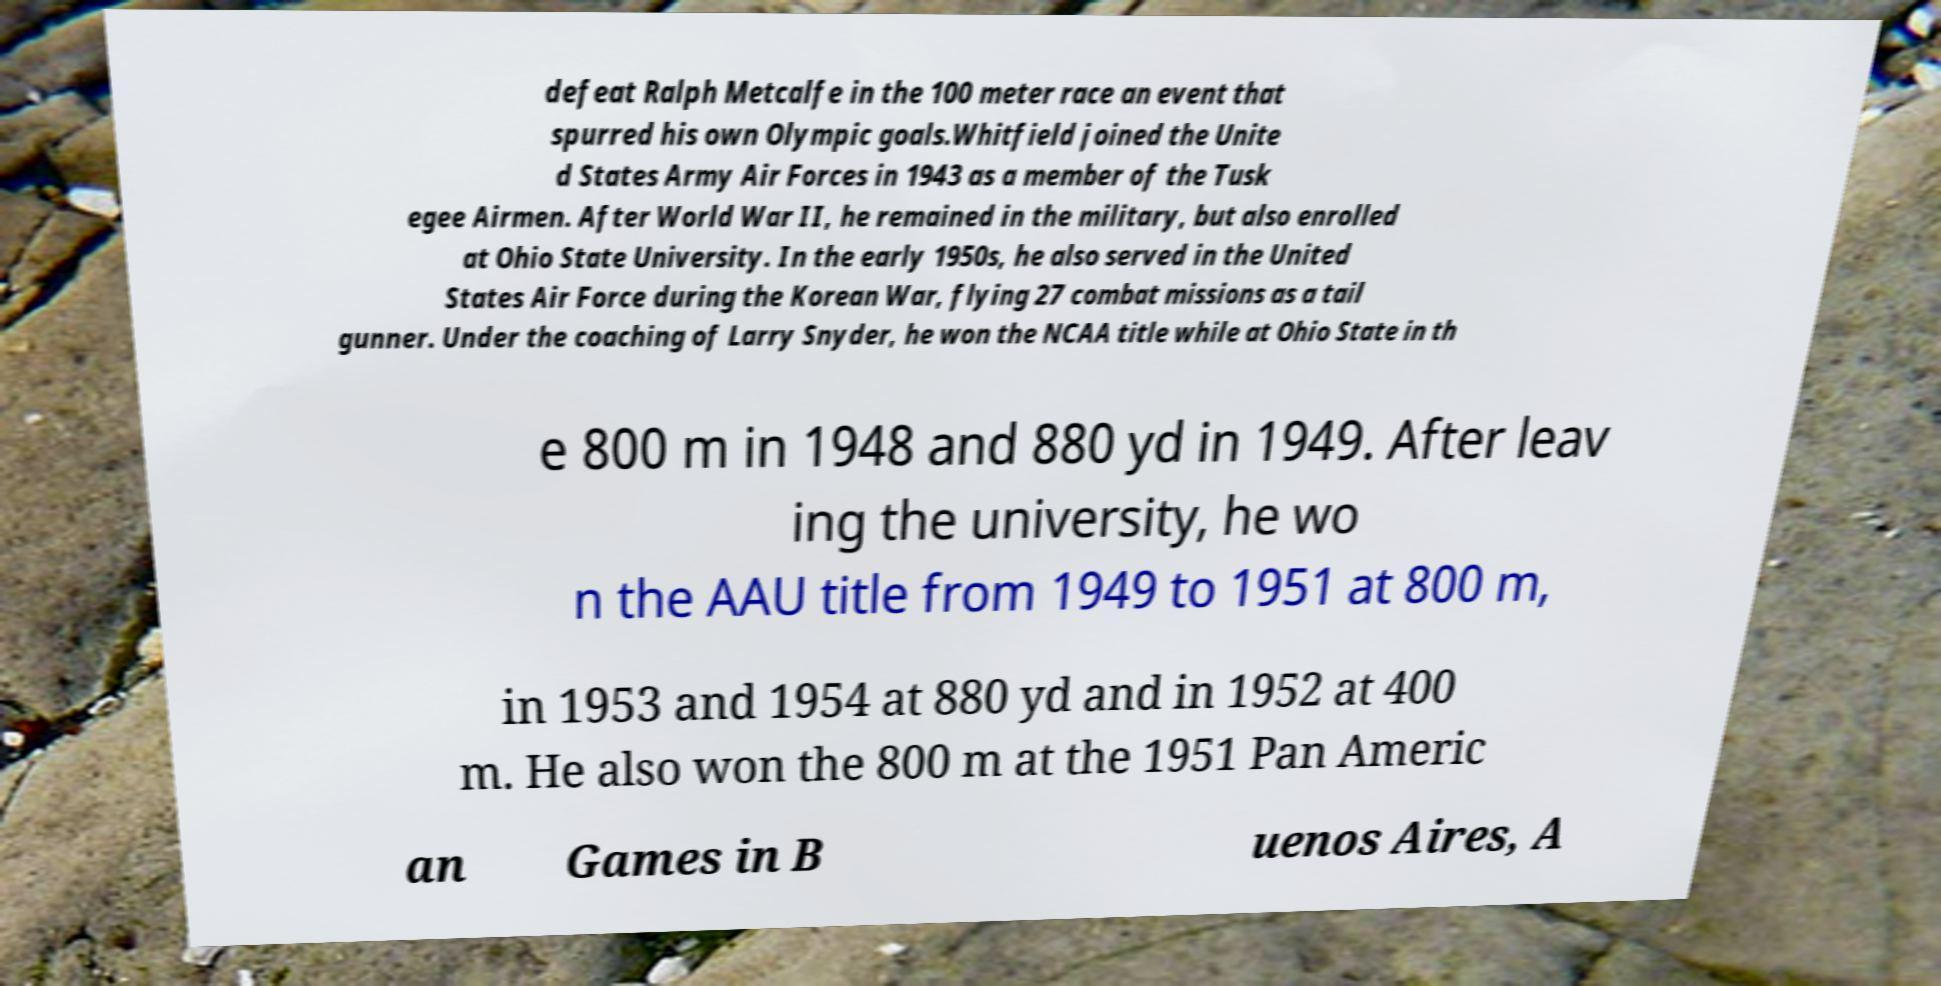I need the written content from this picture converted into text. Can you do that? defeat Ralph Metcalfe in the 100 meter race an event that spurred his own Olympic goals.Whitfield joined the Unite d States Army Air Forces in 1943 as a member of the Tusk egee Airmen. After World War II, he remained in the military, but also enrolled at Ohio State University. In the early 1950s, he also served in the United States Air Force during the Korean War, flying 27 combat missions as a tail gunner. Under the coaching of Larry Snyder, he won the NCAA title while at Ohio State in th e 800 m in 1948 and 880 yd in 1949. After leav ing the university, he wo n the AAU title from 1949 to 1951 at 800 m, in 1953 and 1954 at 880 yd and in 1952 at 400 m. He also won the 800 m at the 1951 Pan Americ an Games in B uenos Aires, A 